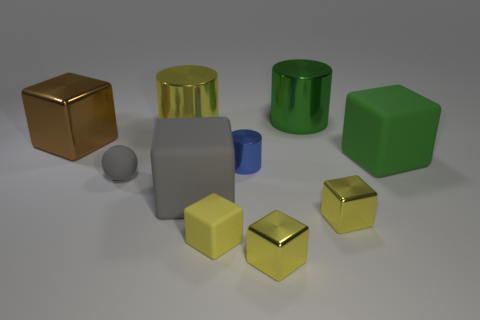Is there another big object that has the same material as the large yellow object?
Make the answer very short. Yes. Do the large gray cube and the gray ball have the same material?
Make the answer very short. Yes. What number of large things are in front of the big green thing that is to the left of the big green rubber cube?
Give a very brief answer. 4. What number of red things are either big metallic cubes or small metallic things?
Ensure brevity in your answer.  0. The yellow metal thing that is to the left of the metal block in front of the small matte thing that is in front of the small sphere is what shape?
Offer a very short reply. Cylinder. What color is the other metal cube that is the same size as the gray block?
Your answer should be compact. Brown. What number of other gray things have the same shape as the large gray object?
Offer a very short reply. 0. Do the yellow matte block and the yellow metal thing behind the large gray matte object have the same size?
Offer a very short reply. No. There is a tiny metallic object that is in front of the yellow block to the left of the tiny blue thing; what shape is it?
Your answer should be compact. Cube. Are there fewer large rubber blocks left of the green matte cube than purple matte blocks?
Your response must be concise. No. 